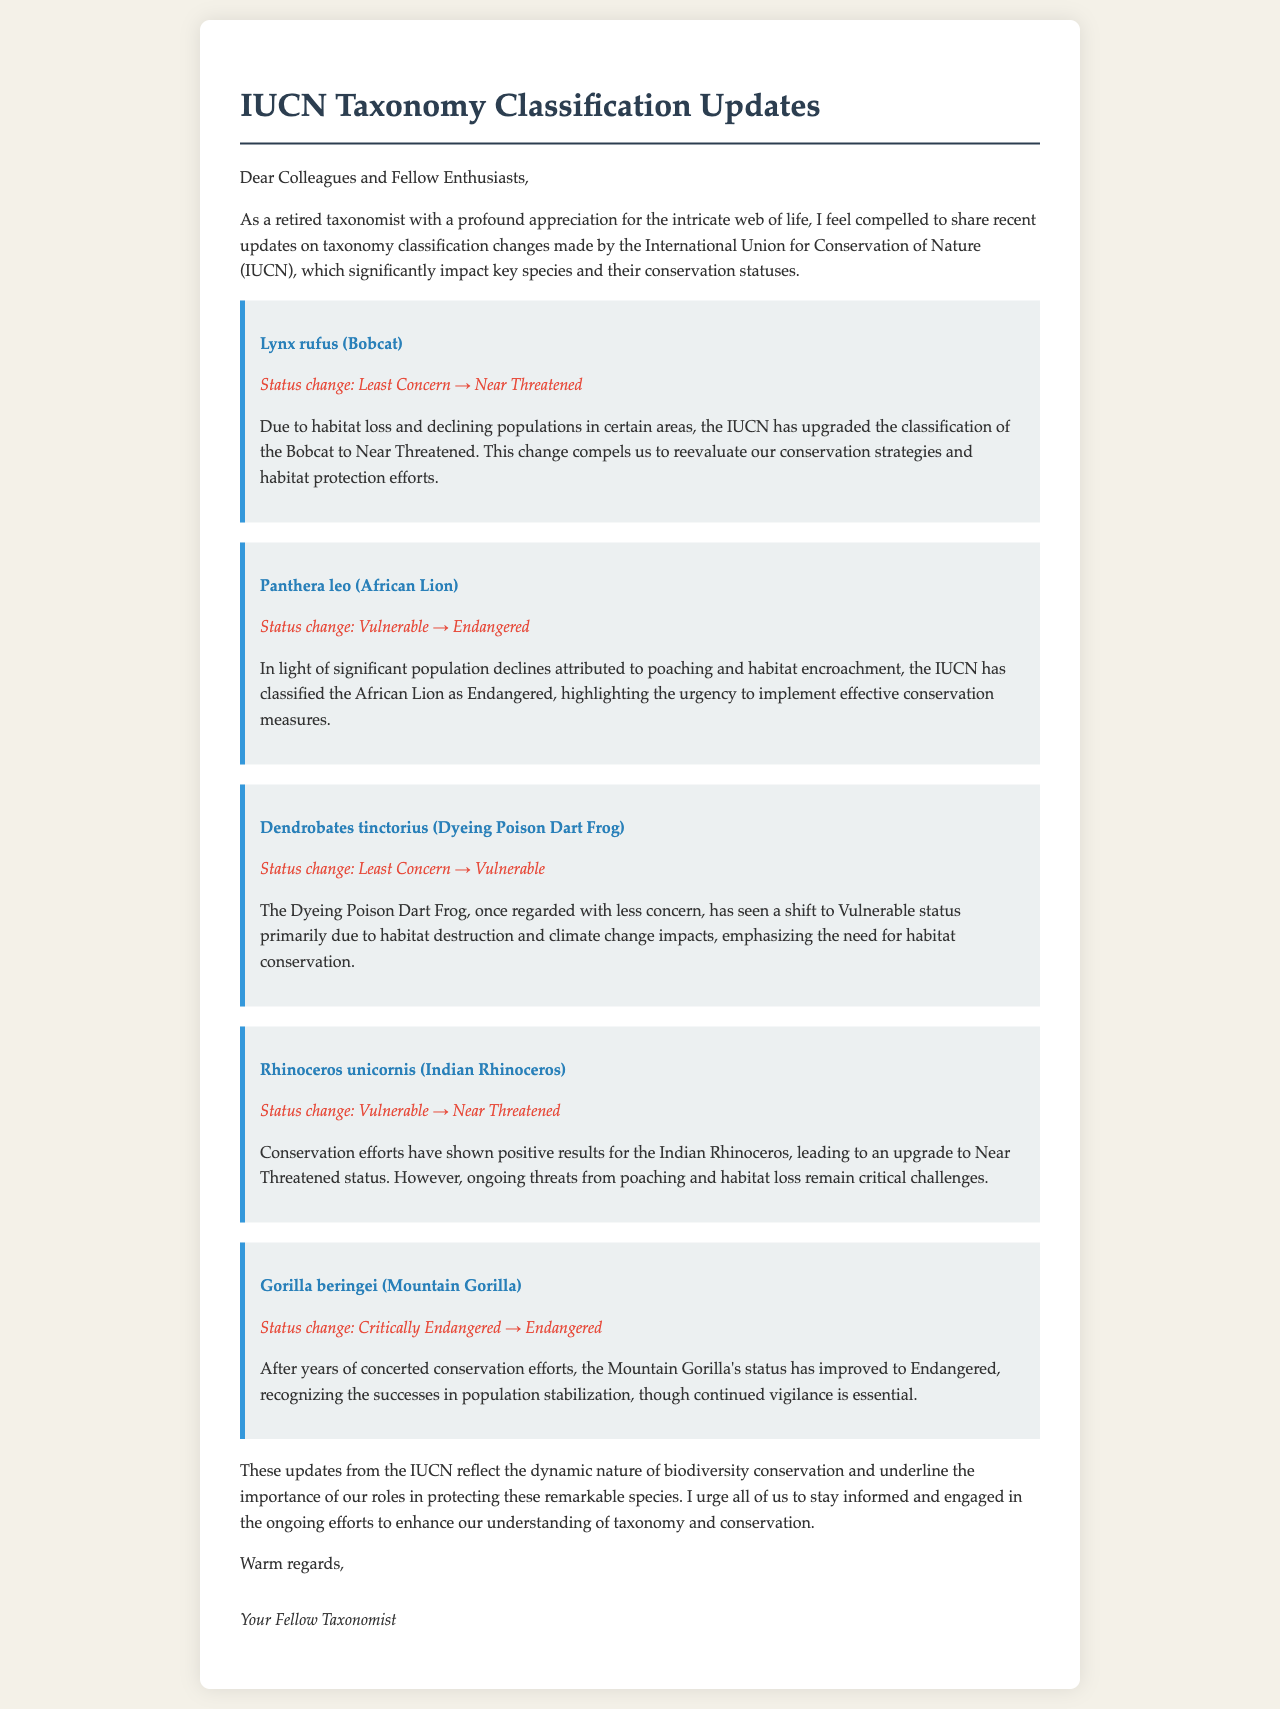What is the status change for Lynx rufus? The status change for Lynx rufus is from Least Concern to Near Threatened.
Answer: Least Concern → Near Threatened What species was upgraded from Vulnerable to Endangered? The species upgraded from Vulnerable to Endangered is Panthera leo.
Answer: Panthera leo What has caused the Dyeing Poison Dart Frog's status to change? The Dyeing Poison Dart Frog's status changed primarily due to habitat destruction and climate change impacts.
Answer: Habitat destruction and climate change Which species experienced a status change to Near Threatened despite previous vulnerabilities? The species that experienced a status change to Near Threatened is Rhinoceros unicornis.
Answer: Rhinoceros unicornis What does the update on the Mountain Gorilla indicate about conservation efforts? The update indicates that concerted conservation efforts have led to the Mountain Gorilla's status improvement to Endangered.
Answer: Status improvement to Endangered Who is the letter addressed to? The letter is addressed to colleagues and fellow enthusiasts in the field.
Answer: Colleagues and fellow enthusiasts How many key species updates are mentioned in the document? There are five key species updates mentioned in the document.
Answer: Five What is the overall theme of the IUCN taxonomy updates? The overall theme is the dynamic nature of biodiversity conservation.
Answer: Dynamic nature of biodiversity conservation What is the closing salutation in the letter? The closing salutation in the letter is "Warm regards."
Answer: Warm regards 